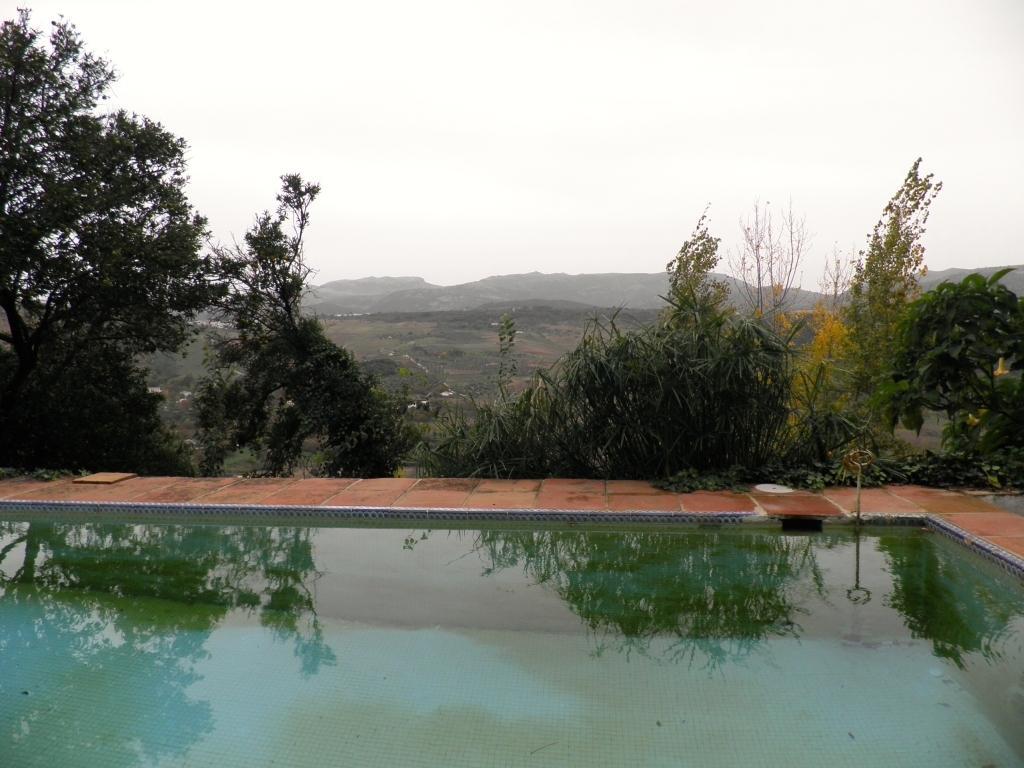Please provide a concise description of this image. In this image we can see sky, hills, ground, trees and a swimming pool. 